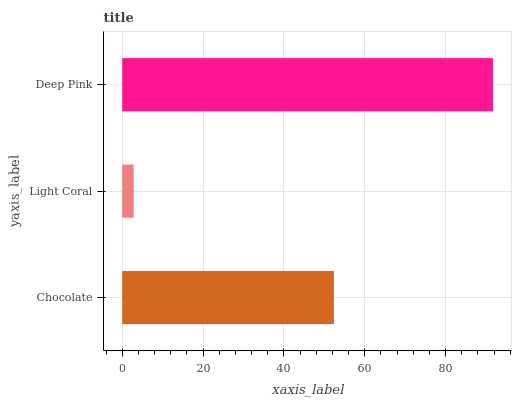Is Light Coral the minimum?
Answer yes or no. Yes. Is Deep Pink the maximum?
Answer yes or no. Yes. Is Deep Pink the minimum?
Answer yes or no. No. Is Light Coral the maximum?
Answer yes or no. No. Is Deep Pink greater than Light Coral?
Answer yes or no. Yes. Is Light Coral less than Deep Pink?
Answer yes or no. Yes. Is Light Coral greater than Deep Pink?
Answer yes or no. No. Is Deep Pink less than Light Coral?
Answer yes or no. No. Is Chocolate the high median?
Answer yes or no. Yes. Is Chocolate the low median?
Answer yes or no. Yes. Is Deep Pink the high median?
Answer yes or no. No. Is Light Coral the low median?
Answer yes or no. No. 